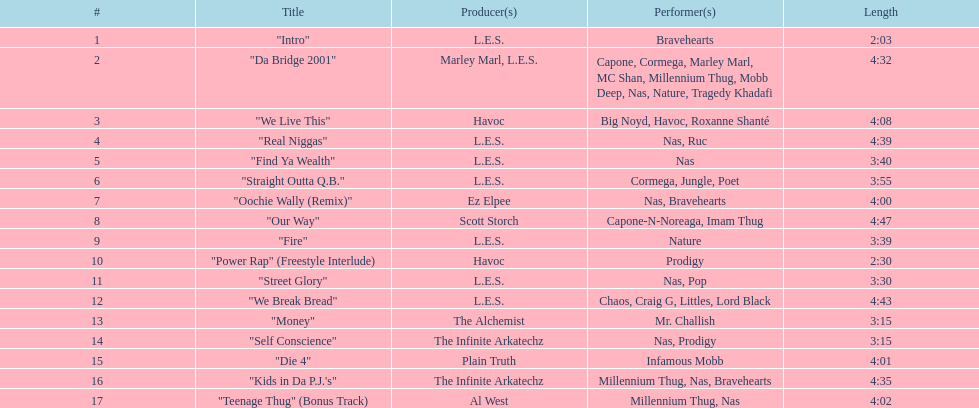How many songs were on the track list? 17. 